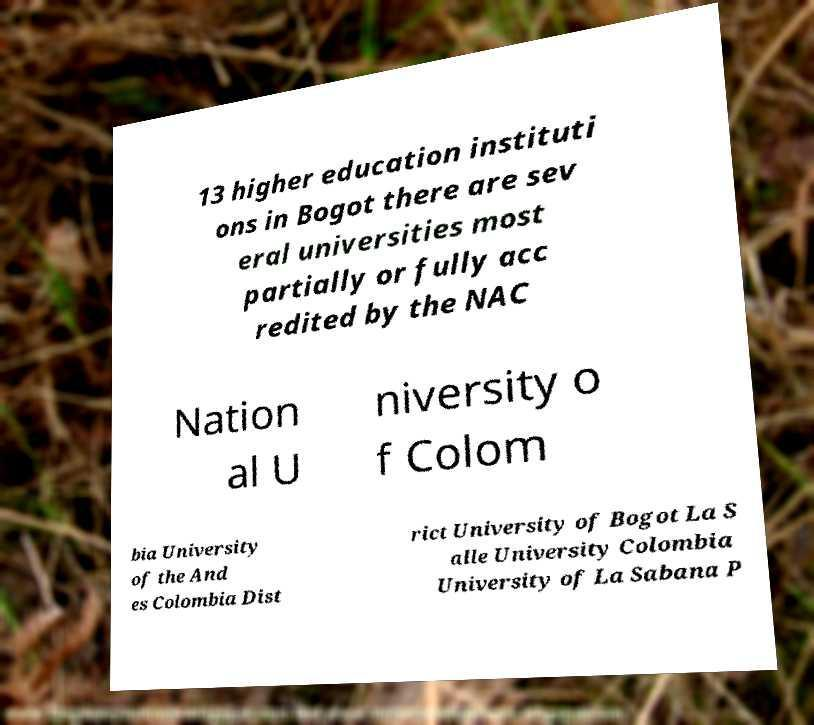Could you assist in decoding the text presented in this image and type it out clearly? 13 higher education instituti ons in Bogot there are sev eral universities most partially or fully acc redited by the NAC Nation al U niversity o f Colom bia University of the And es Colombia Dist rict University of Bogot La S alle University Colombia University of La Sabana P 